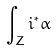Convert formula to latex. <formula><loc_0><loc_0><loc_500><loc_500>\int _ { Z } i ^ { * } \alpha</formula> 